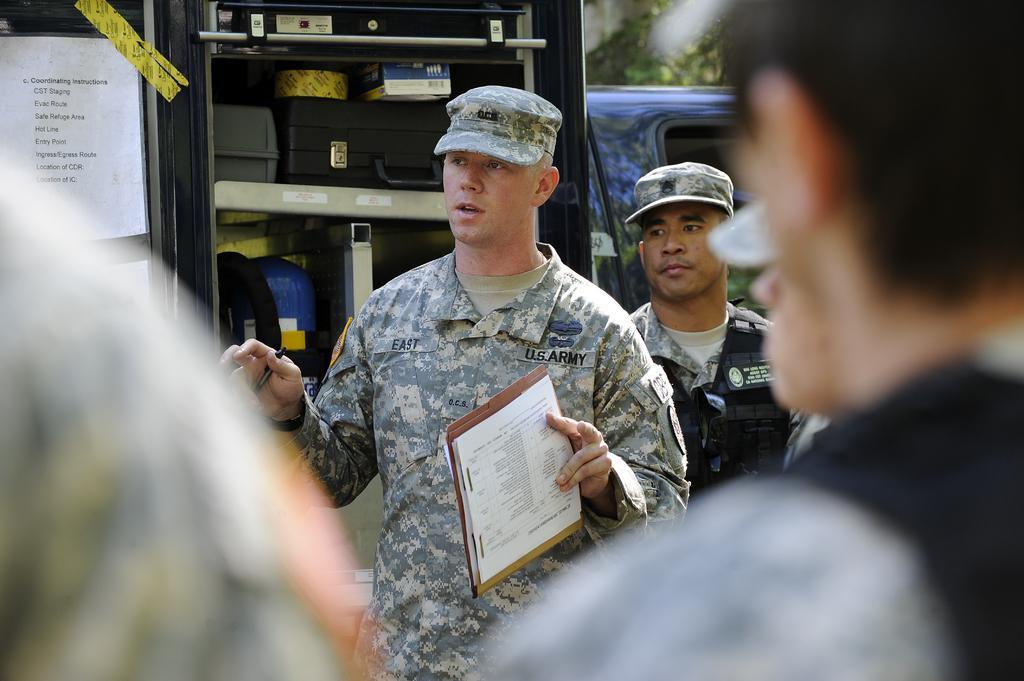Can you describe this image briefly? In this image there is an army personnel holding papers and a pen in his hand, behind him there is another army personnel, in front of him there are a few other army personnel's, behind him there is a truck with some objects in it. 